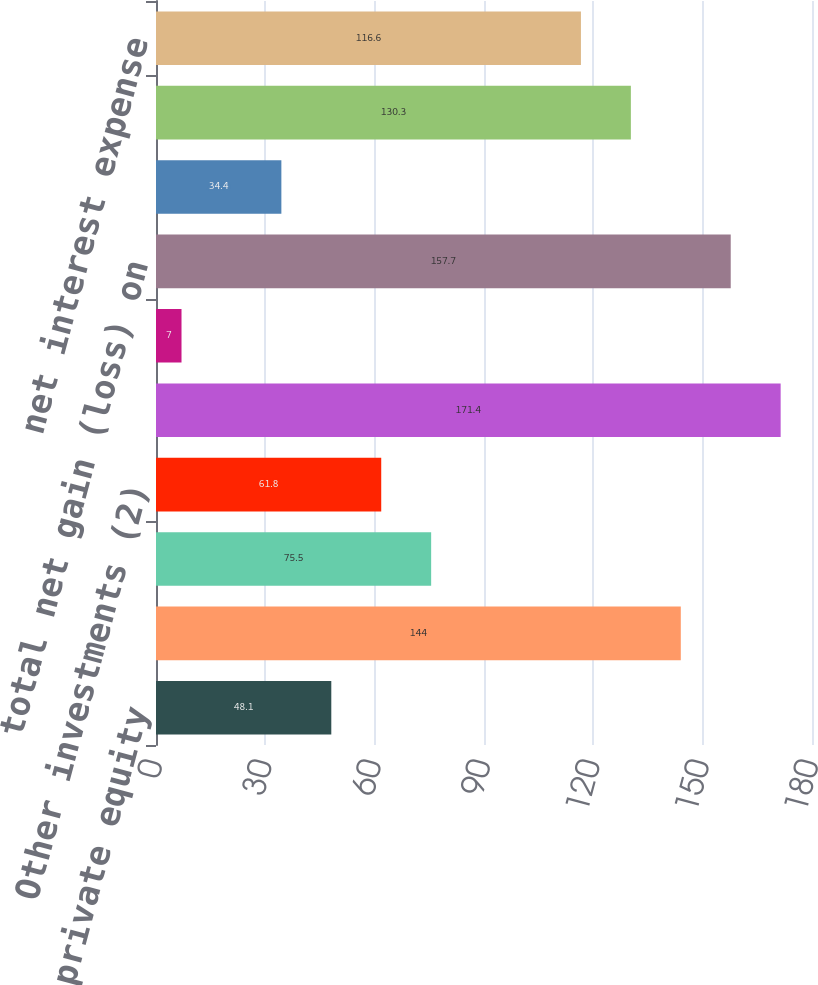<chart> <loc_0><loc_0><loc_500><loc_500><bar_chart><fcel>private equity<fcel>Real estate<fcel>distressed credit/mortgage<fcel>Other investments (2)<fcel>Sub-total<fcel>investments related to<fcel>total net gain (loss) on<fcel>interest and dividend income<fcel>interest expense<fcel>net interest expense<nl><fcel>48.1<fcel>144<fcel>75.5<fcel>61.8<fcel>171.4<fcel>7<fcel>157.7<fcel>34.4<fcel>130.3<fcel>116.6<nl></chart> 